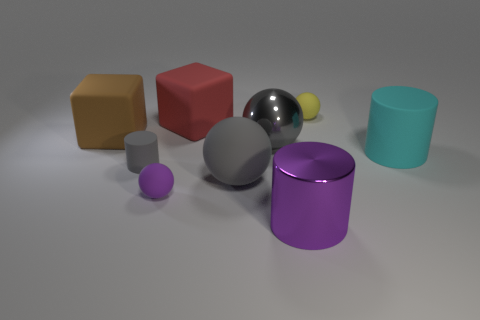There is a cylinder that is made of the same material as the large cyan thing; what color is it?
Keep it short and to the point. Gray. Does the gray ball that is in front of the cyan matte cylinder have the same size as the brown block?
Provide a short and direct response. Yes. The small object that is the same shape as the large purple metal thing is what color?
Give a very brief answer. Gray. What is the shape of the tiny rubber object behind the big block on the left side of the rubber cylinder that is left of the big matte cylinder?
Offer a terse response. Sphere. Is the shape of the large cyan object the same as the big purple shiny object?
Provide a short and direct response. Yes. There is a big gray thing to the right of the gray rubber thing right of the small cylinder; what is its shape?
Ensure brevity in your answer.  Sphere. Are there any tiny things?
Your answer should be very brief. Yes. There is a purple thing behind the large cylinder in front of the tiny purple rubber sphere; what number of blocks are to the right of it?
Your answer should be compact. 1. Is the shape of the tiny yellow thing the same as the large purple shiny thing in front of the large gray rubber object?
Give a very brief answer. No. Is the number of purple matte objects greater than the number of matte cylinders?
Your answer should be compact. No. 